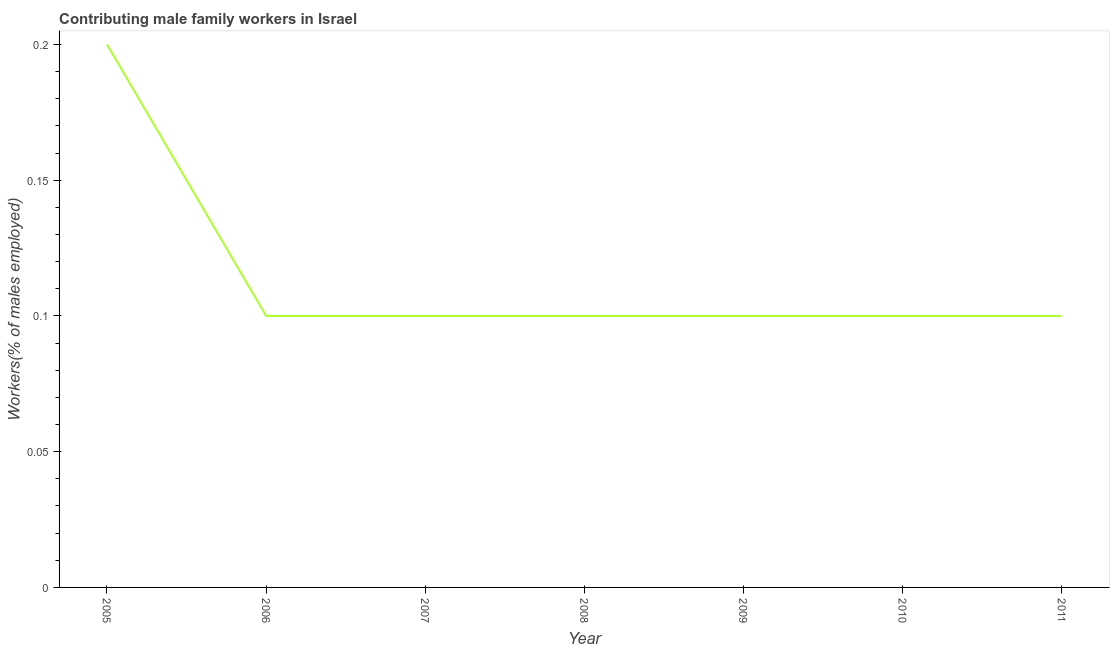What is the contributing male family workers in 2006?
Provide a succinct answer. 0.1. Across all years, what is the maximum contributing male family workers?
Your answer should be compact. 0.2. Across all years, what is the minimum contributing male family workers?
Keep it short and to the point. 0.1. In which year was the contributing male family workers maximum?
Your answer should be compact. 2005. What is the sum of the contributing male family workers?
Your answer should be very brief. 0.8. What is the average contributing male family workers per year?
Provide a short and direct response. 0.11. What is the median contributing male family workers?
Your response must be concise. 0.1. Is the contributing male family workers in 2009 less than that in 2011?
Give a very brief answer. No. Is the difference between the contributing male family workers in 2005 and 2007 greater than the difference between any two years?
Offer a very short reply. Yes. What is the difference between the highest and the second highest contributing male family workers?
Make the answer very short. 0.1. Is the sum of the contributing male family workers in 2007 and 2009 greater than the maximum contributing male family workers across all years?
Offer a very short reply. No. What is the difference between the highest and the lowest contributing male family workers?
Make the answer very short. 0.1. How many lines are there?
Keep it short and to the point. 1. How many years are there in the graph?
Make the answer very short. 7. What is the difference between two consecutive major ticks on the Y-axis?
Offer a terse response. 0.05. Does the graph contain grids?
Offer a very short reply. No. What is the title of the graph?
Offer a terse response. Contributing male family workers in Israel. What is the label or title of the Y-axis?
Your response must be concise. Workers(% of males employed). What is the Workers(% of males employed) in 2005?
Offer a terse response. 0.2. What is the Workers(% of males employed) in 2006?
Provide a short and direct response. 0.1. What is the Workers(% of males employed) of 2007?
Make the answer very short. 0.1. What is the Workers(% of males employed) in 2008?
Provide a succinct answer. 0.1. What is the Workers(% of males employed) in 2009?
Ensure brevity in your answer.  0.1. What is the Workers(% of males employed) of 2010?
Keep it short and to the point. 0.1. What is the Workers(% of males employed) in 2011?
Your answer should be compact. 0.1. What is the difference between the Workers(% of males employed) in 2005 and 2007?
Provide a succinct answer. 0.1. What is the difference between the Workers(% of males employed) in 2005 and 2009?
Ensure brevity in your answer.  0.1. What is the difference between the Workers(% of males employed) in 2005 and 2010?
Offer a very short reply. 0.1. What is the difference between the Workers(% of males employed) in 2006 and 2007?
Offer a very short reply. 0. What is the difference between the Workers(% of males employed) in 2009 and 2011?
Provide a succinct answer. 0. What is the ratio of the Workers(% of males employed) in 2005 to that in 2008?
Give a very brief answer. 2. What is the ratio of the Workers(% of males employed) in 2005 to that in 2011?
Make the answer very short. 2. What is the ratio of the Workers(% of males employed) in 2006 to that in 2010?
Your answer should be compact. 1. What is the ratio of the Workers(% of males employed) in 2006 to that in 2011?
Keep it short and to the point. 1. What is the ratio of the Workers(% of males employed) in 2007 to that in 2010?
Your answer should be compact. 1. What is the ratio of the Workers(% of males employed) in 2007 to that in 2011?
Your answer should be compact. 1. What is the ratio of the Workers(% of males employed) in 2008 to that in 2010?
Keep it short and to the point. 1. What is the ratio of the Workers(% of males employed) in 2008 to that in 2011?
Give a very brief answer. 1. What is the ratio of the Workers(% of males employed) in 2010 to that in 2011?
Provide a short and direct response. 1. 